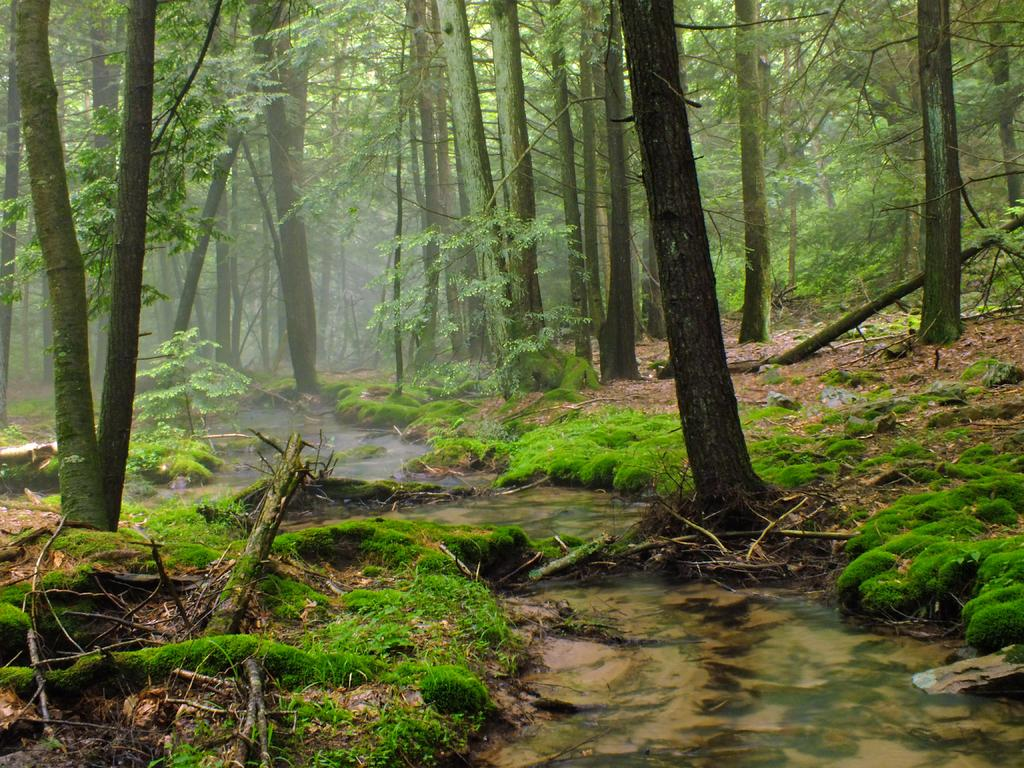What type of vegetation can be seen in the image? There are many trees, plants, and grass in the image. Can you describe the water feature in the image? There is a water flow in the center of the image. What type of stocking is hanging from the tree in the image? There is no stocking hanging from any tree in the image. 